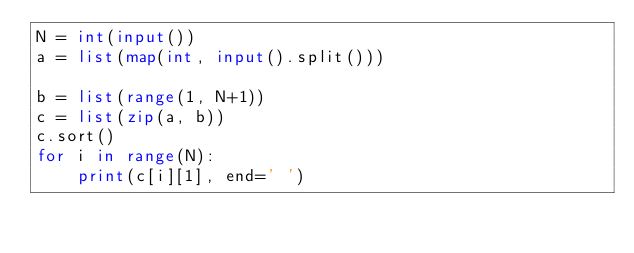<code> <loc_0><loc_0><loc_500><loc_500><_Python_>N = int(input())
a = list(map(int, input().split()))

b = list(range(1, N+1))
c = list(zip(a, b))
c.sort()
for i in range(N):
    print(c[i][1], end=' ')</code> 